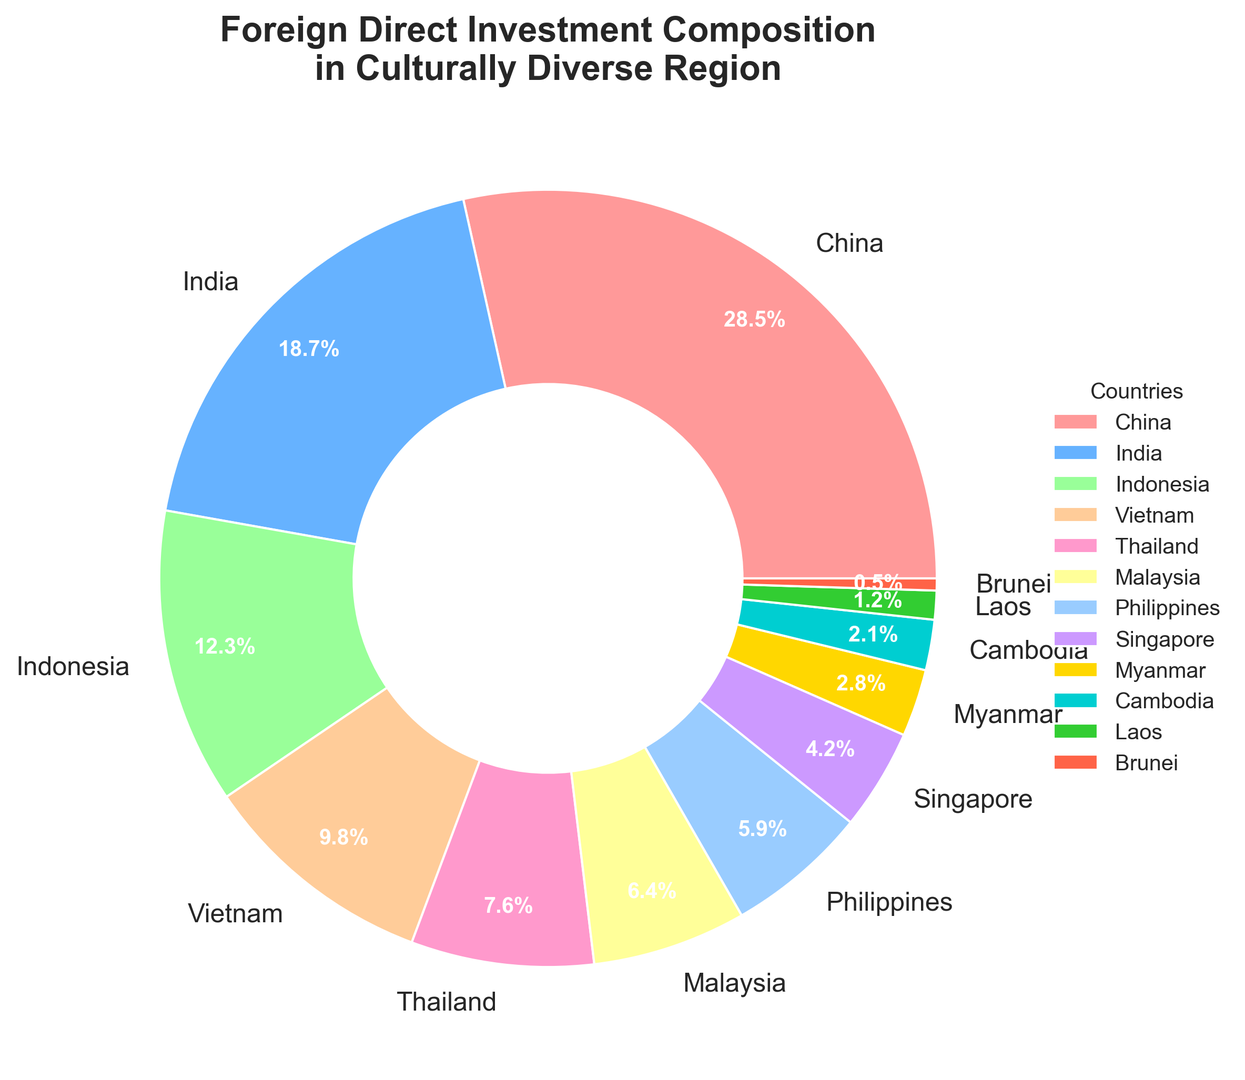What country receives the highest percentage of foreign direct investment? The country with the largest slice in the pie chart is China, which is represented by 28.5%. This is the highest percentage among all listed countries.
Answer: China Which two countries combined receive just over a quarter of the total foreign direct investment? By observing the pie chart, we see that Thailand (7.6%) and Malaysia (6.4%) together account for 7.6% + 6.4%, which equals 14%. Since this is less than a quarter (25%), we instead look at Vietnam (9.8%) and Thailand (7.6%). Combined, they account for 9.8% + 7.6% = 17.4%. Thus, we need to go up the list a bit more. We see that Indonesia (12.3%) and Vietnam (9.8%) combined give us 12.3% + 9.8% = 22.1%. Finally, India (18.7%) and Indonesia (12.3%) give us 18.7% + 12.3% = 31%, slightly above a quarter. Hence, the two countries combined receiving just over a quarter are Indonesia and India.
Answer: India and Indonesia What is the difference in foreign direct investment percentage between the country with the highest investment and the country with the lowest? The country with the highest investment is China at 28.5%, and the country with the lowest is Brunei at 0.5%. The difference in their percentages is 28.5% - 0.5% = 28%.
Answer: 28% Which countries receive less than 5% each of the total foreign direct investment? By looking at the slices representing the individual countries, we see that Singapore (4.2%), Myanmar (2.8%), Cambodia (2.1%), Laos (1.2%), and Brunei (0.5%) each receive less than 5% of the total foreign direct investment.
Answer: Singapore, Myanmar, Cambodia, Laos, Brunei What is the total percentage of foreign direct investment received by the bottom five countries combined? Adding the percentages from the bottom five slices: Philippines (5.9%), Singapore (4.2%), Myanmar (2.8%), Cambodia (2.1%), and Laos (1.2%) gives us 5.9% + 4.2% + 2.8% + 2.1% + 1.2% = 16.2%.
Answer: 16.2% Which country represented by the green color receives how much percentage of the foreign direct investment? Upon visual inspection, the green slice represents Malaysia. The attached label for Malaysia indicates a percentage of 6.4%.
Answer: Malaysia, 6.4% Is the percentage of foreign direct investment received by Indonesia greater than that received by Vietnam and Thailand combined? From the chart, Indonesia receives 12.3%. Vietnam and Thailand combined receive 9.8% + 7.6% = 17.4%. Since 12.3% is less than 17.4%, Indonesia receives less investment.
Answer: No Which country represented by the yellowish-gold color receives how much percentage of the foreign direct investment? The yellowish-golf color slice corresponds to the Philippines. The label indicates that the Philippines receives 5.9% of the foreign direct investment.
Answer: Philippines, 5.9% What percentage of foreign direct investment does Vietnam receive, and how does it rank compared to other countries? Vietnam receives 9.8% of foreign direct investment. Comparing this to other slices, it is positioned after China, India, and Indonesia, making it the fourth highest.
Answer: 9.8%, fourth 